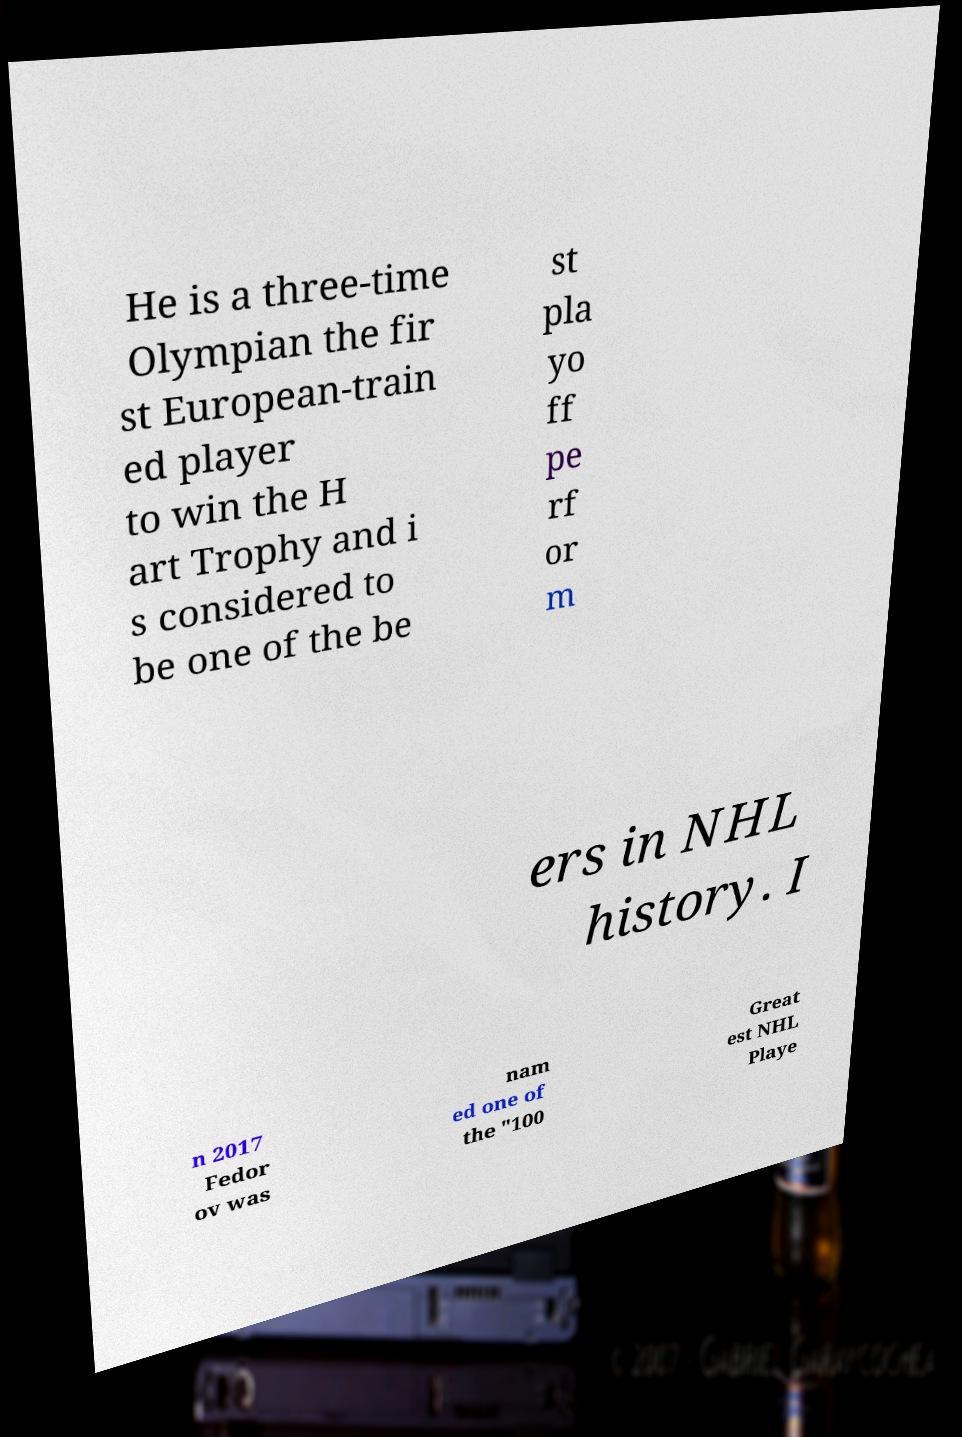What messages or text are displayed in this image? I need them in a readable, typed format. He is a three-time Olympian the fir st European-train ed player to win the H art Trophy and i s considered to be one of the be st pla yo ff pe rf or m ers in NHL history. I n 2017 Fedor ov was nam ed one of the "100 Great est NHL Playe 